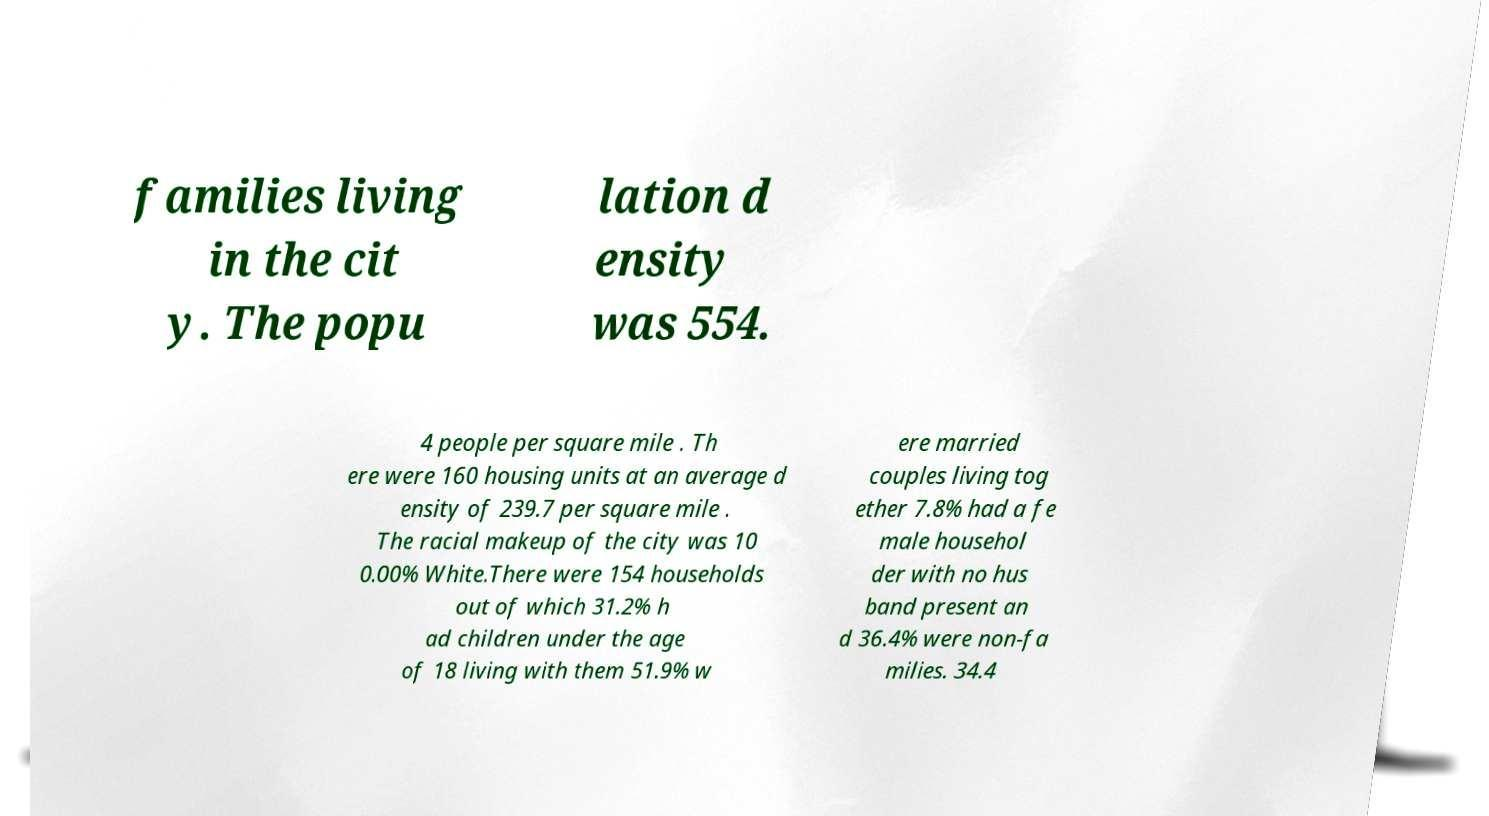Please read and relay the text visible in this image. What does it say? families living in the cit y. The popu lation d ensity was 554. 4 people per square mile . Th ere were 160 housing units at an average d ensity of 239.7 per square mile . The racial makeup of the city was 10 0.00% White.There were 154 households out of which 31.2% h ad children under the age of 18 living with them 51.9% w ere married couples living tog ether 7.8% had a fe male househol der with no hus band present an d 36.4% were non-fa milies. 34.4 